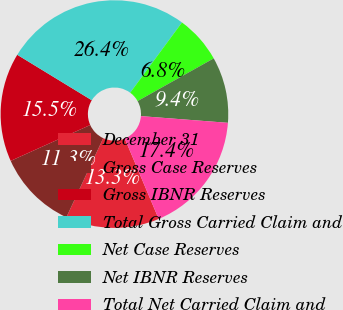Convert chart. <chart><loc_0><loc_0><loc_500><loc_500><pie_chart><fcel>December 31<fcel>Gross Case Reserves<fcel>Gross IBNR Reserves<fcel>Total Gross Carried Claim and<fcel>Net Case Reserves<fcel>Net IBNR Reserves<fcel>Total Net Carried Claim and<nl><fcel>13.29%<fcel>11.32%<fcel>15.46%<fcel>26.39%<fcel>6.75%<fcel>9.36%<fcel>17.42%<nl></chart> 